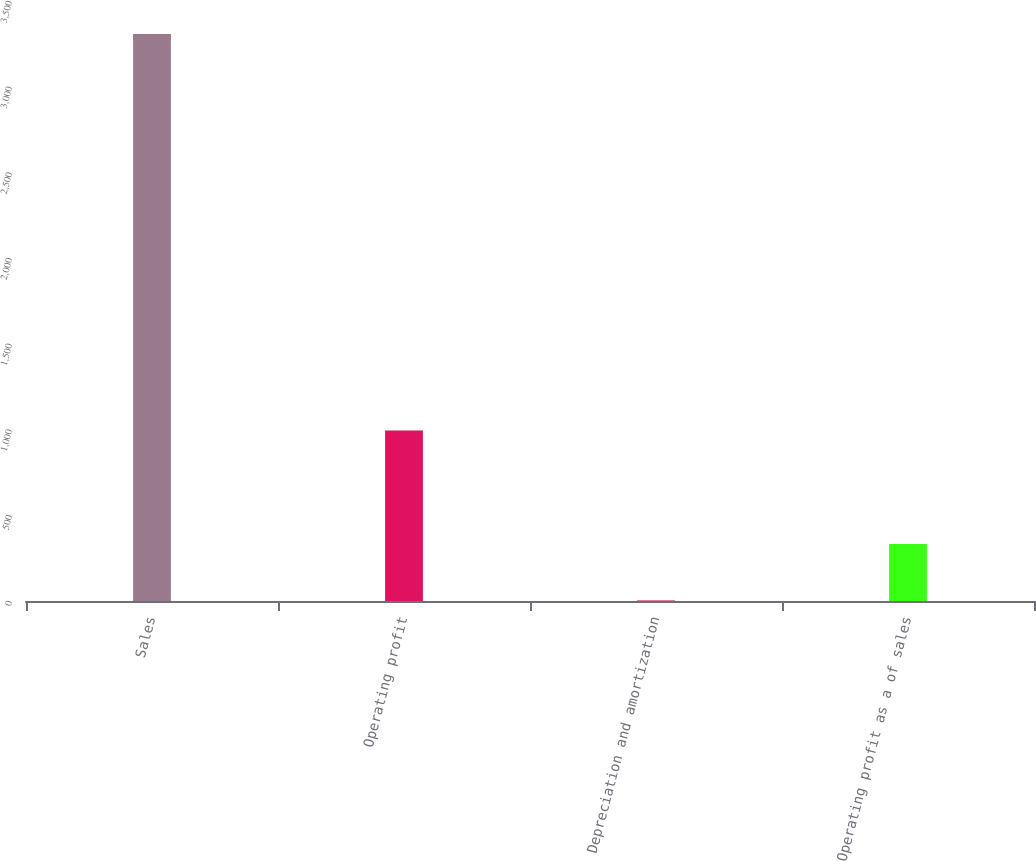<chart> <loc_0><loc_0><loc_500><loc_500><bar_chart><fcel>Sales<fcel>Operating profit<fcel>Depreciation and amortization<fcel>Operating profit as a of sales<nl><fcel>3307.9<fcel>994.05<fcel>2.4<fcel>332.95<nl></chart> 